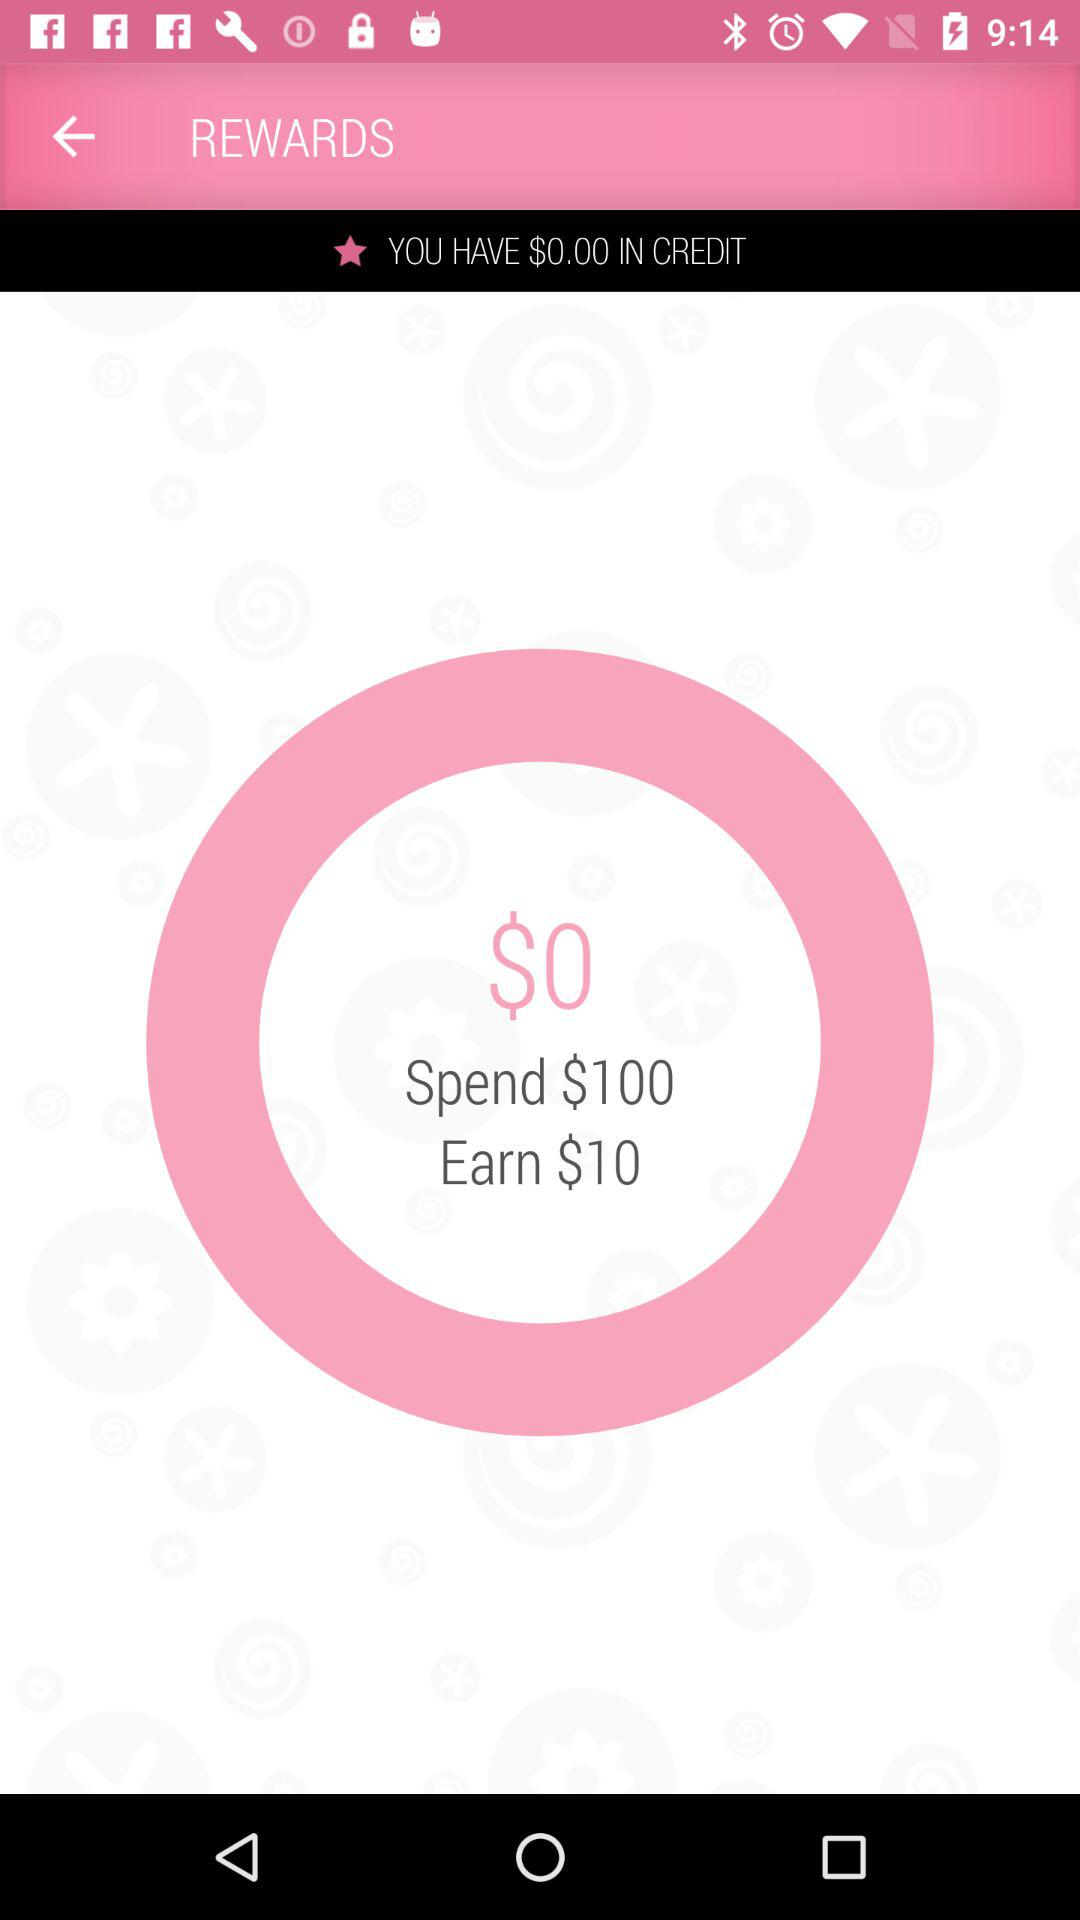What is the amount to be spent? The amount to be spent is $100. 